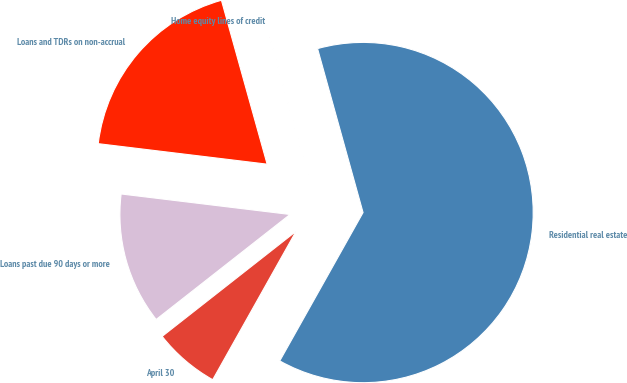Convert chart to OTSL. <chart><loc_0><loc_0><loc_500><loc_500><pie_chart><fcel>April 30<fcel>Residential real estate<fcel>Home equity lines of credit<fcel>Loans and TDRs on non-accrual<fcel>Loans past due 90 days or more<nl><fcel>6.27%<fcel>62.45%<fcel>0.02%<fcel>18.75%<fcel>12.51%<nl></chart> 